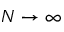<formula> <loc_0><loc_0><loc_500><loc_500>N \to \infty</formula> 